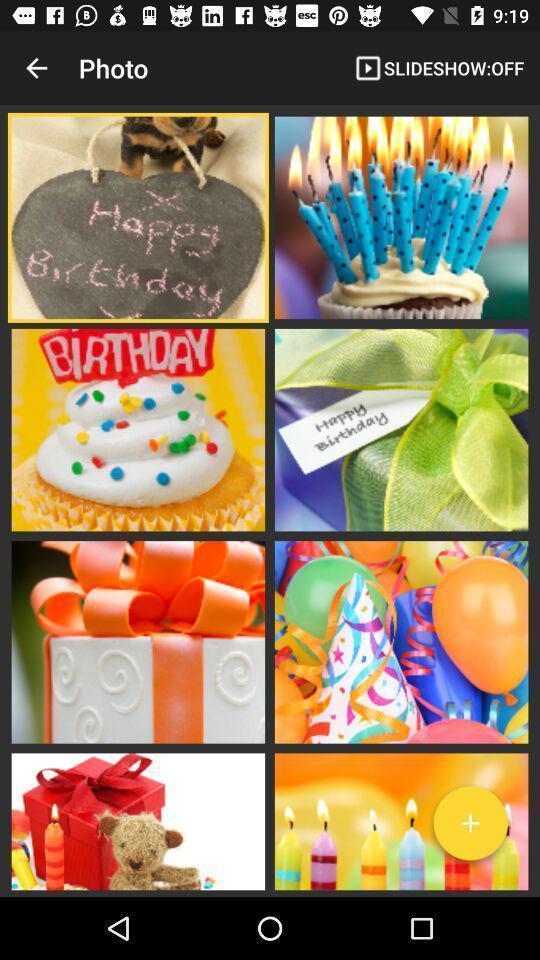Provide a textual representation of this image. Screen showing list of photos. 